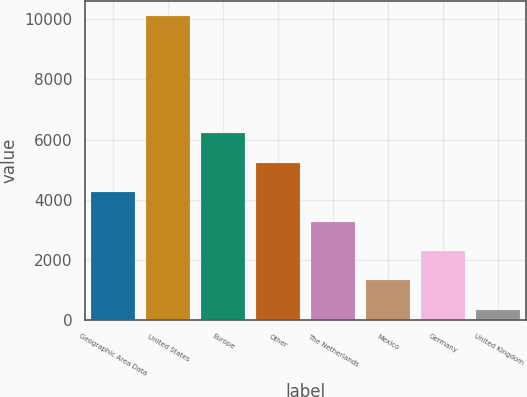Convert chart to OTSL. <chart><loc_0><loc_0><loc_500><loc_500><bar_chart><fcel>Geographic Area Data<fcel>United States<fcel>Europe<fcel>Other<fcel>The Netherlands<fcel>Mexico<fcel>Germany<fcel>United Kingdom<nl><fcel>4247.84<fcel>10106.3<fcel>6200.66<fcel>5224.25<fcel>3271.43<fcel>1318.61<fcel>2295.02<fcel>342.2<nl></chart> 